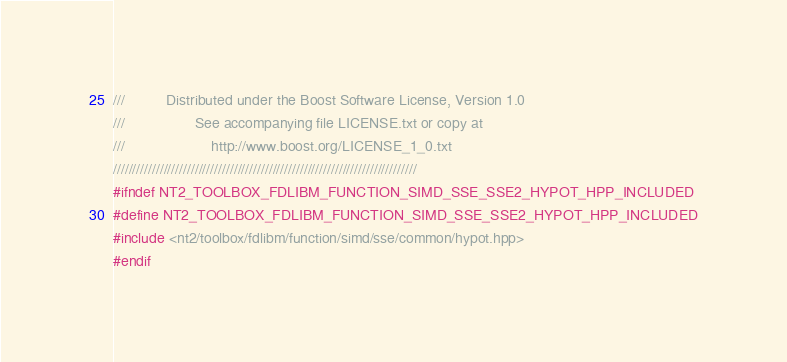Convert code to text. <code><loc_0><loc_0><loc_500><loc_500><_C++_>///          Distributed under the Boost Software License, Version 1.0
///                 See accompanying file LICENSE.txt or copy at
///                     http://www.boost.org/LICENSE_1_0.txt
//////////////////////////////////////////////////////////////////////////////
#ifndef NT2_TOOLBOX_FDLIBM_FUNCTION_SIMD_SSE_SSE2_HYPOT_HPP_INCLUDED
#define NT2_TOOLBOX_FDLIBM_FUNCTION_SIMD_SSE_SSE2_HYPOT_HPP_INCLUDED
#include <nt2/toolbox/fdlibm/function/simd/sse/common/hypot.hpp>
#endif
</code> 